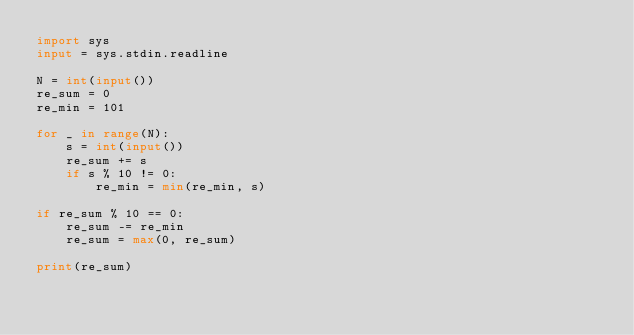<code> <loc_0><loc_0><loc_500><loc_500><_Python_>import sys
input = sys.stdin.readline

N = int(input())
re_sum = 0
re_min = 101

for _ in range(N):
    s = int(input())
    re_sum += s
    if s % 10 != 0:
        re_min = min(re_min, s)

if re_sum % 10 == 0:
    re_sum -= re_min
    re_sum = max(0, re_sum)

print(re_sum)</code> 